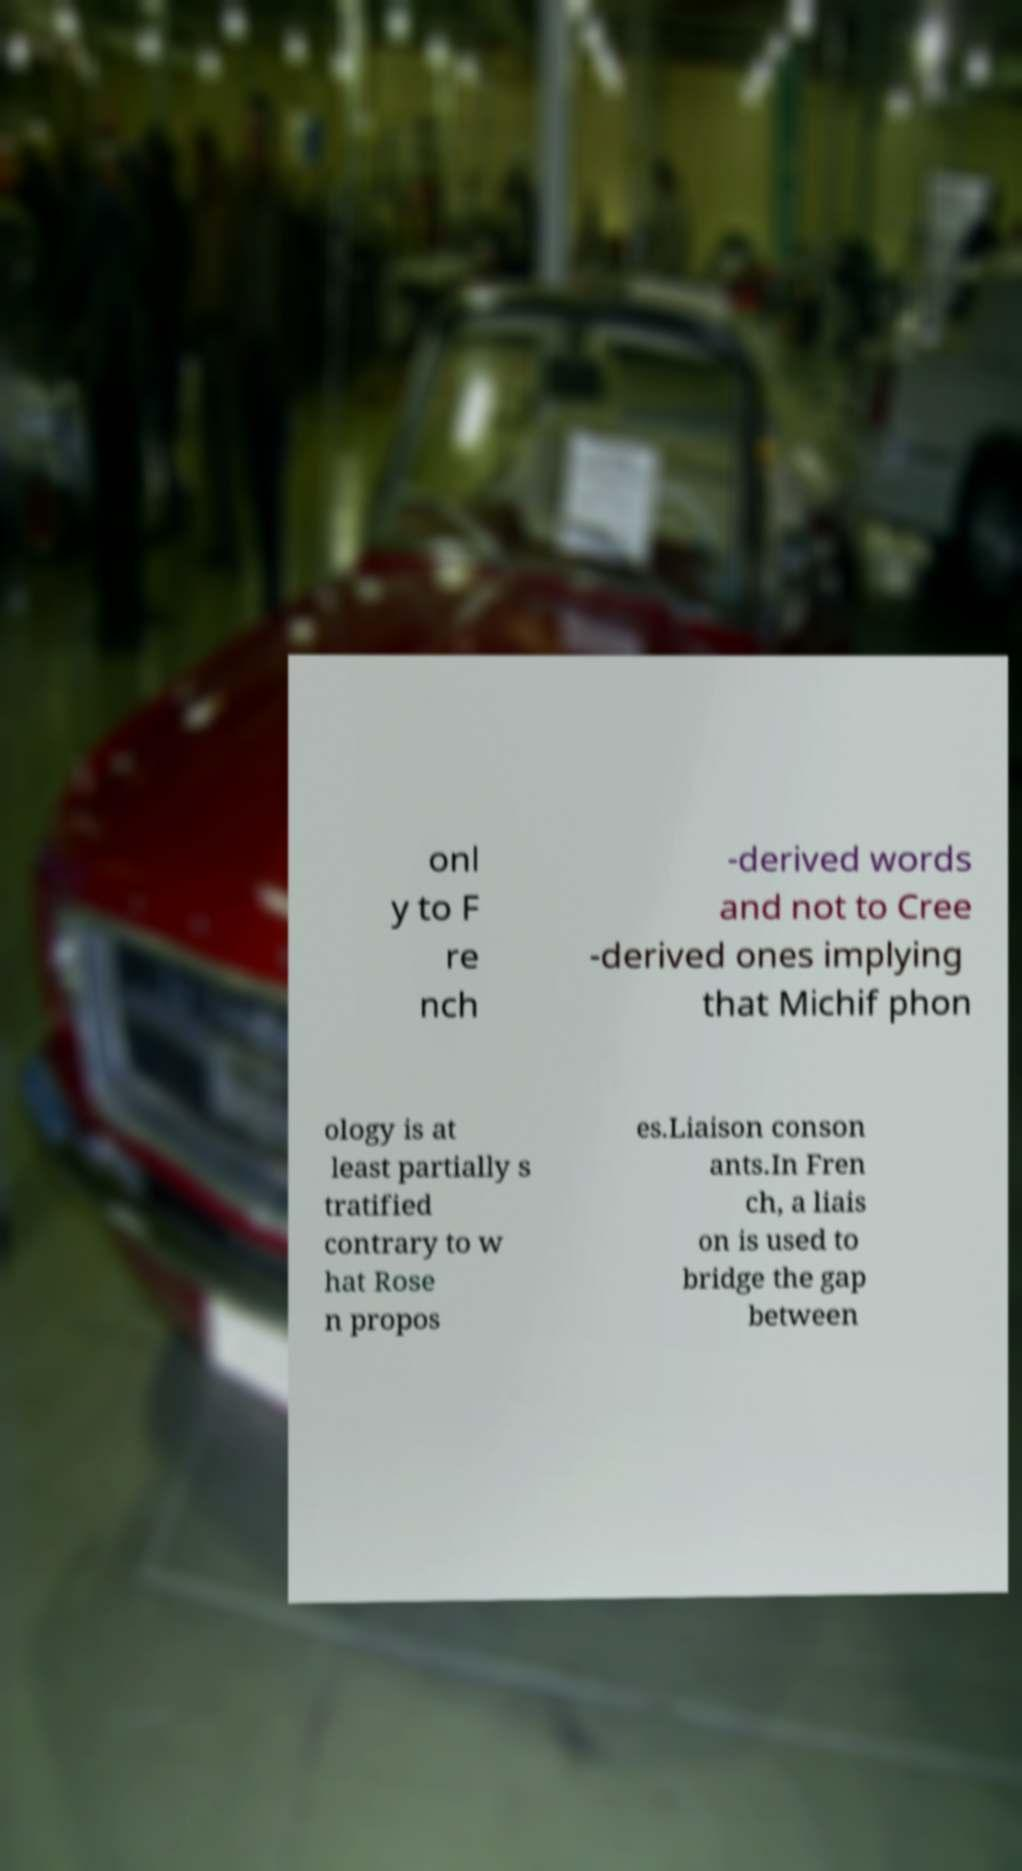I need the written content from this picture converted into text. Can you do that? onl y to F re nch -derived words and not to Cree -derived ones implying that Michif phon ology is at least partially s tratified contrary to w hat Rose n propos es.Liaison conson ants.In Fren ch, a liais on is used to bridge the gap between 